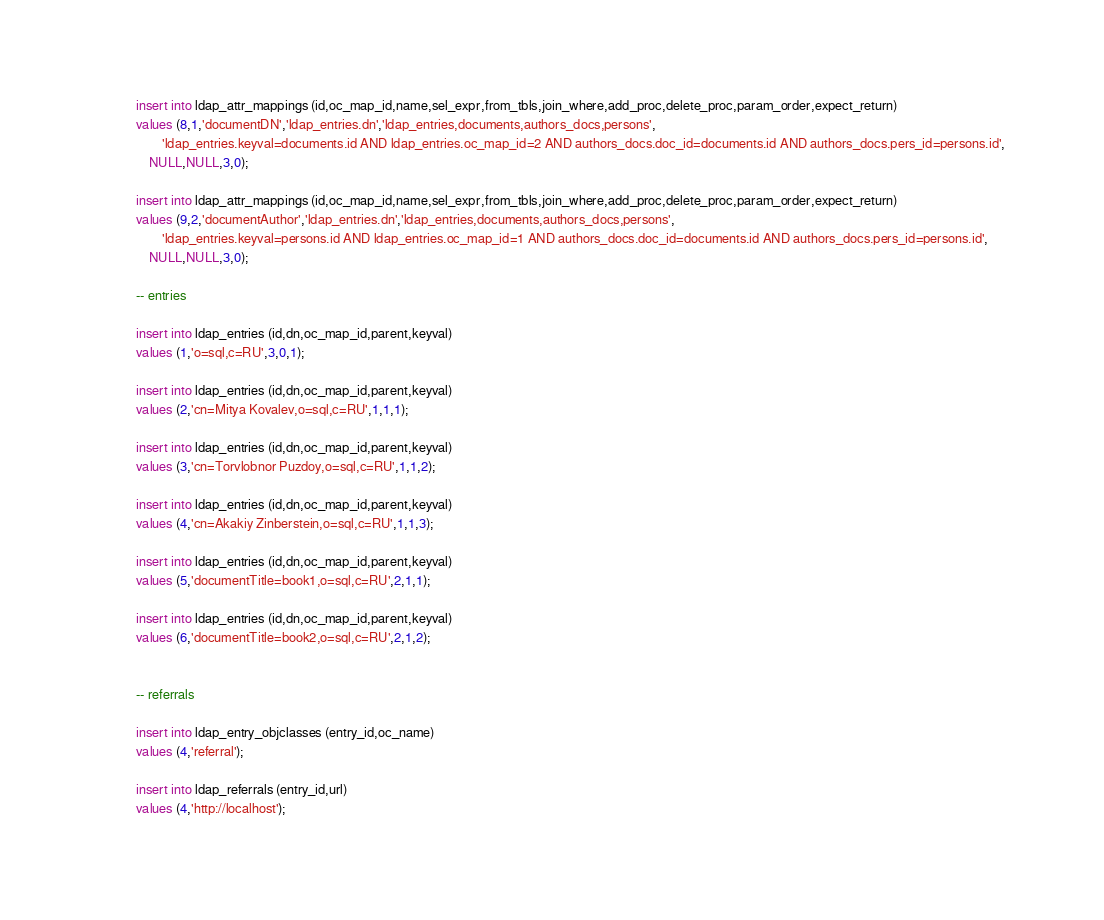<code> <loc_0><loc_0><loc_500><loc_500><_SQL_>insert into ldap_attr_mappings (id,oc_map_id,name,sel_expr,from_tbls,join_where,add_proc,delete_proc,param_order,expect_return)
values (8,1,'documentDN','ldap_entries.dn','ldap_entries,documents,authors_docs,persons',
        'ldap_entries.keyval=documents.id AND ldap_entries.oc_map_id=2 AND authors_docs.doc_id=documents.id AND authors_docs.pers_id=persons.id',
	NULL,NULL,3,0);

insert into ldap_attr_mappings (id,oc_map_id,name,sel_expr,from_tbls,join_where,add_proc,delete_proc,param_order,expect_return)
values (9,2,'documentAuthor','ldap_entries.dn','ldap_entries,documents,authors_docs,persons',
        'ldap_entries.keyval=persons.id AND ldap_entries.oc_map_id=1 AND authors_docs.doc_id=documents.id AND authors_docs.pers_id=persons.id',
	NULL,NULL,3,0);
	
-- entries
	
insert into ldap_entries (id,dn,oc_map_id,parent,keyval)
values (1,'o=sql,c=RU',3,0,1);

insert into ldap_entries (id,dn,oc_map_id,parent,keyval)
values (2,'cn=Mitya Kovalev,o=sql,c=RU',1,1,1);

insert into ldap_entries (id,dn,oc_map_id,parent,keyval)
values (3,'cn=Torvlobnor Puzdoy,o=sql,c=RU',1,1,2);

insert into ldap_entries (id,dn,oc_map_id,parent,keyval)
values (4,'cn=Akakiy Zinberstein,o=sql,c=RU',1,1,3);

insert into ldap_entries (id,dn,oc_map_id,parent,keyval)
values (5,'documentTitle=book1,o=sql,c=RU',2,1,1);

insert into ldap_entries (id,dn,oc_map_id,parent,keyval)
values (6,'documentTitle=book2,o=sql,c=RU',2,1,2);
	
	
-- referrals

insert into ldap_entry_objclasses (entry_id,oc_name)
values (4,'referral');

insert into ldap_referrals (entry_id,url)
values (4,'http://localhost');
</code> 